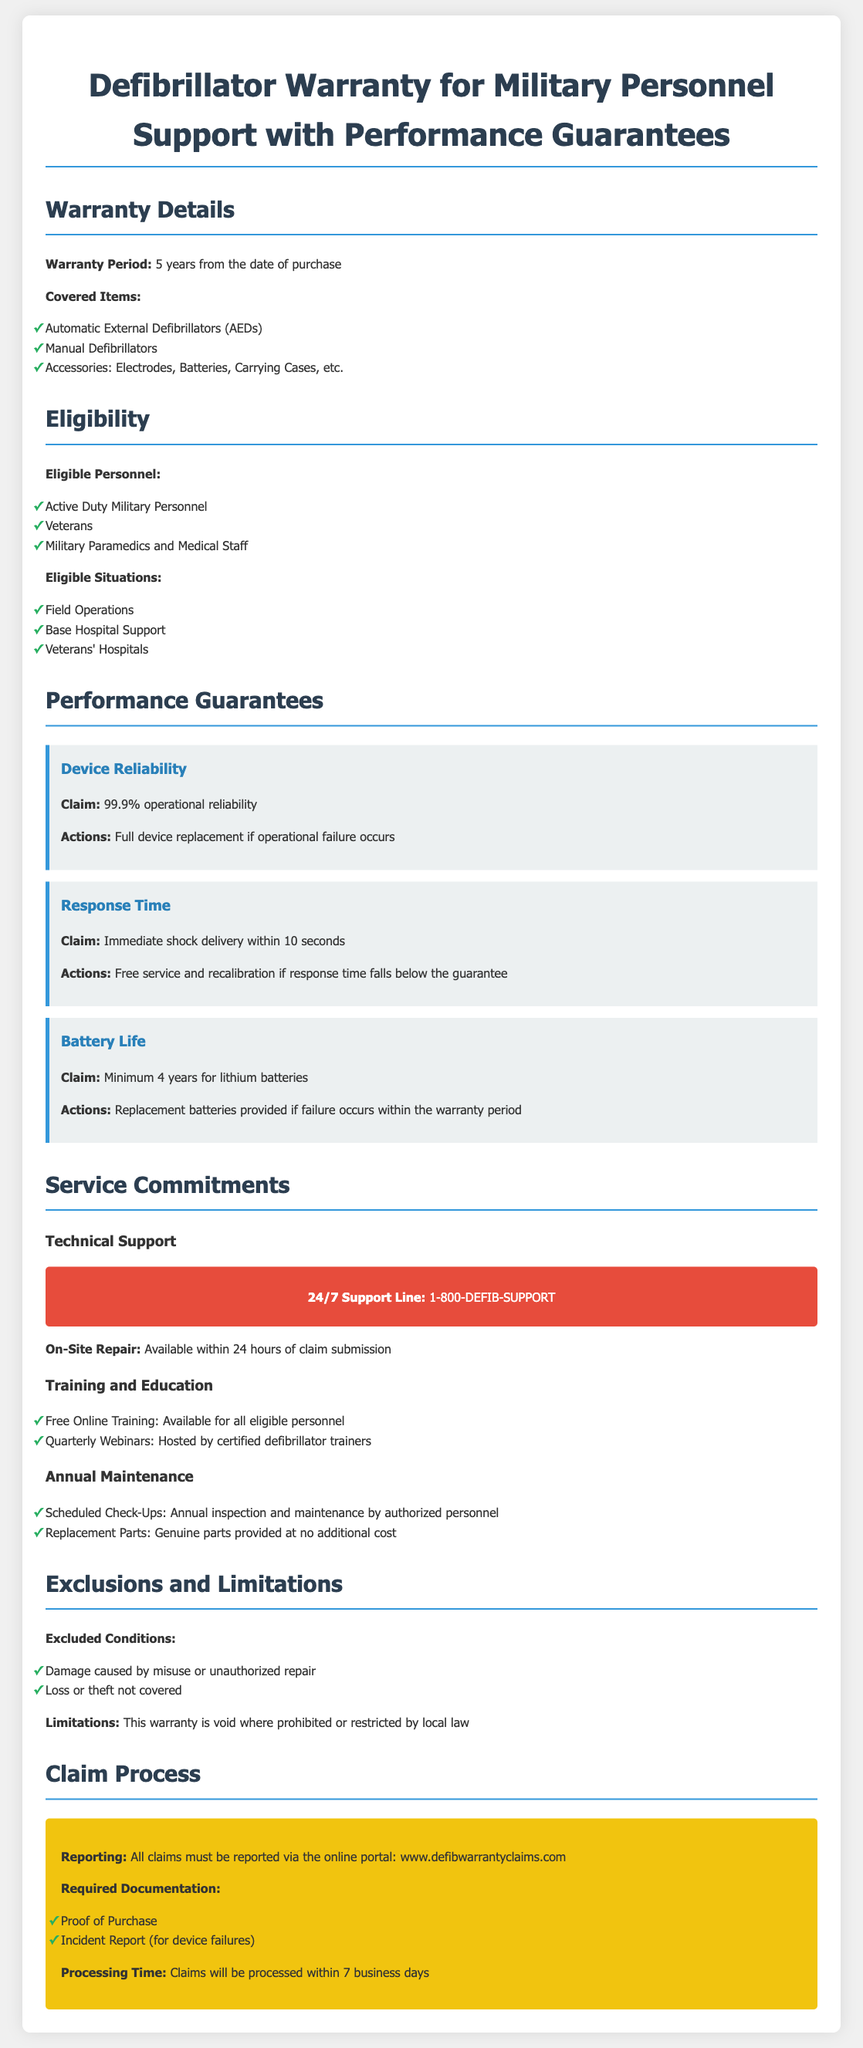What is the warranty period? The warranty period is directly mentioned in the document as lasting for 5 years from the date of purchase.
Answer: 5 years Which items are covered by the warranty? The document lists Automatic External Defibrillators, Manual Defibrillators, and Accessories as the covered items.
Answer: Automatic External Defibrillators, Manual Defibrillators, Accessories Who are the eligible personnel for the warranty? Eligible personnel mentioned include Active Duty Military Personnel, Veterans, and Military Paramedics and Medical Staff.
Answer: Active Duty Military Personnel, Veterans, Military Paramedics and Medical Staff What is the claim for device reliability? The document specifies that the claim for device reliability is 99.9% operational reliability.
Answer: 99.9% operational reliability What should be provided if a battery fails within the warranty period? The document states that replacement batteries will be provided if failure occurs within the warranty period.
Answer: Replacement batteries What is the required documentation for a claim? The required documentation includes Proof of Purchase and an Incident Report for device failures.
Answer: Proof of Purchase, Incident Report How long will claims be processed? The processing time for claims is explicitly stated as within 7 business days.
Answer: 7 business days What is excluded from the warranty? The document clearly mentions damage caused by misuse or unauthorized repair and loss or theft as excluded conditions.
Answer: Damage caused by misuse, unauthorized repair, loss or theft What is the support line for technical support? The document provides the number for the support line, which is 1-800-DEFIB-SUPPORT.
Answer: 1-800-DEFIB-SUPPORT 